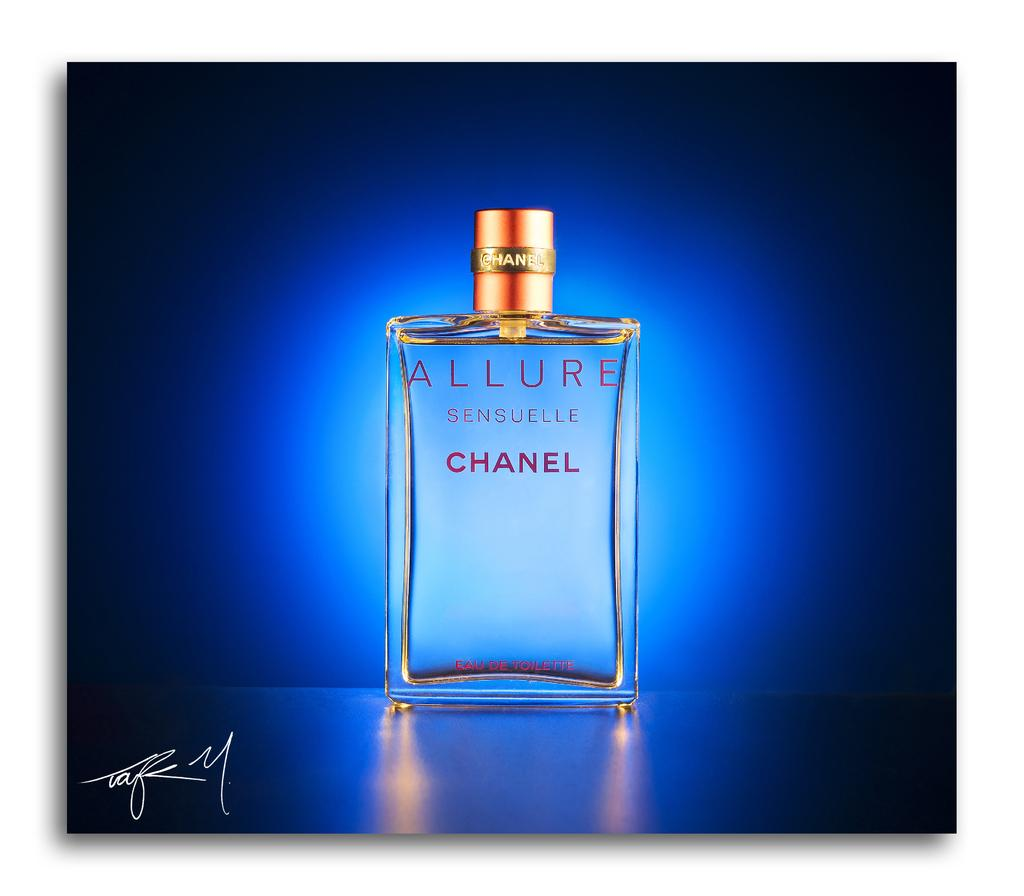<image>
Provide a brief description of the given image. Allure by Chanel is etched into the side of this perfume bottle. 